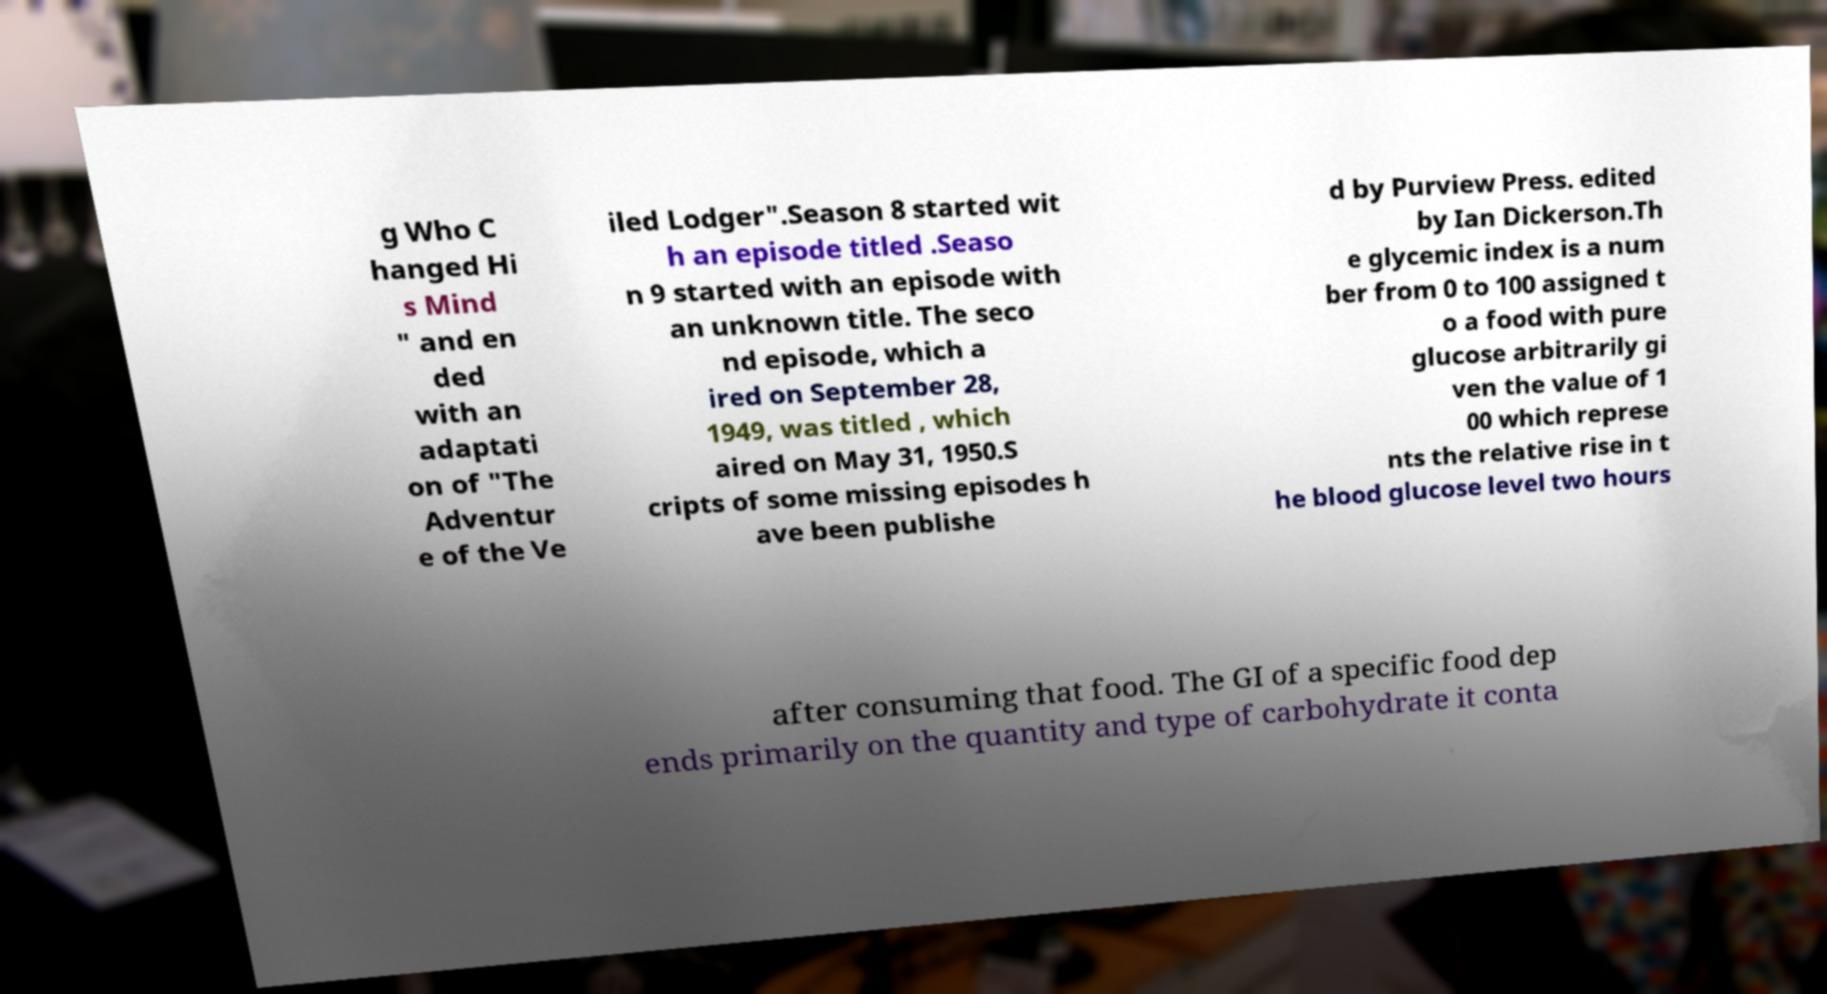Please read and relay the text visible in this image. What does it say? g Who C hanged Hi s Mind " and en ded with an adaptati on of "The Adventur e of the Ve iled Lodger".Season 8 started wit h an episode titled .Seaso n 9 started with an episode with an unknown title. The seco nd episode, which a ired on September 28, 1949, was titled , which aired on May 31, 1950.S cripts of some missing episodes h ave been publishe d by Purview Press. edited by Ian Dickerson.Th e glycemic index is a num ber from 0 to 100 assigned t o a food with pure glucose arbitrarily gi ven the value of 1 00 which represe nts the relative rise in t he blood glucose level two hours after consuming that food. The GI of a specific food dep ends primarily on the quantity and type of carbohydrate it conta 